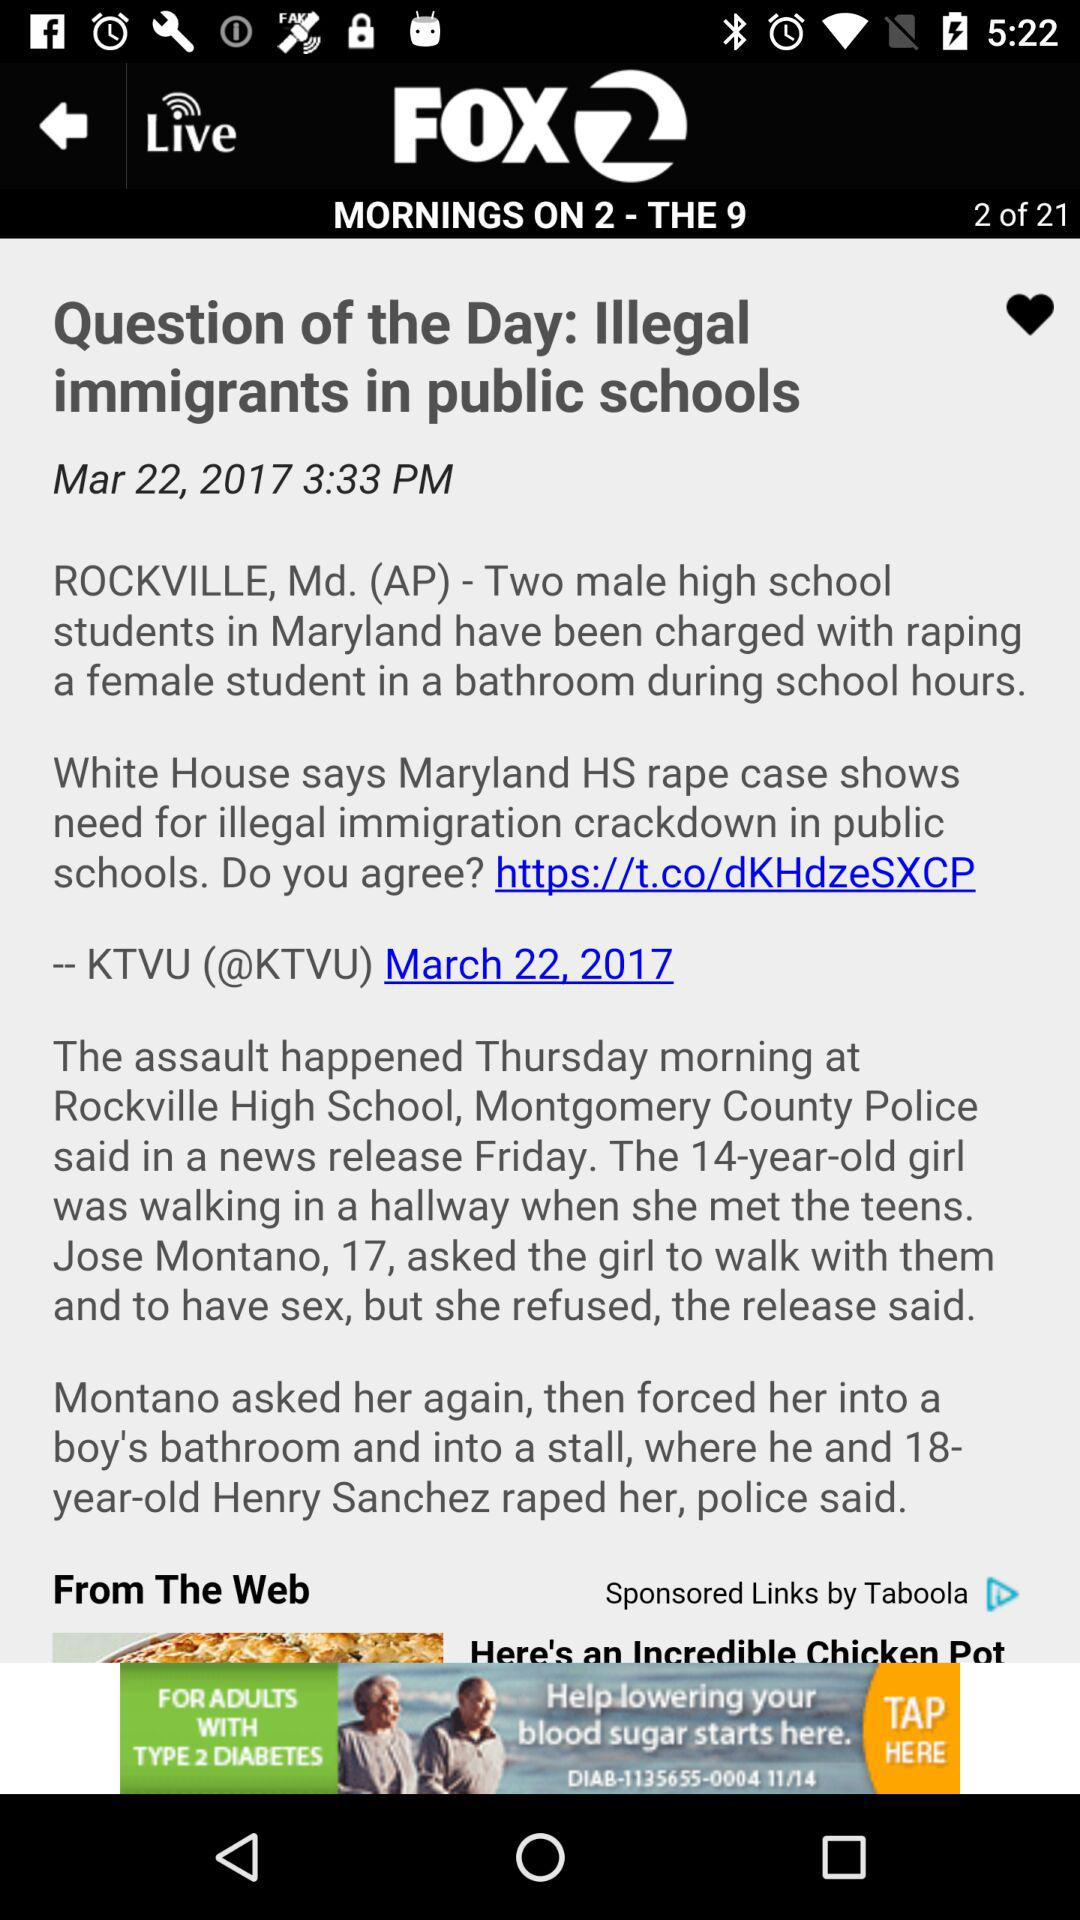What is the current page number? The current page number is 2. 